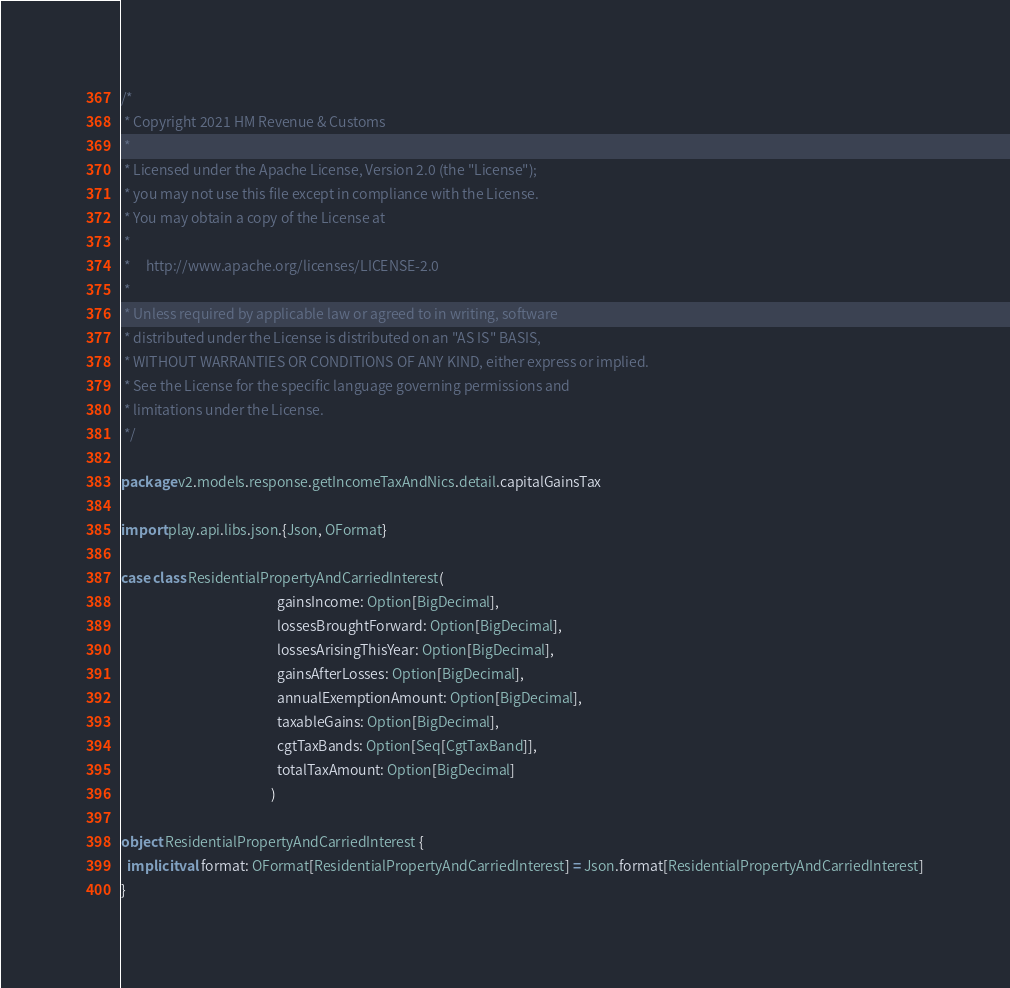Convert code to text. <code><loc_0><loc_0><loc_500><loc_500><_Scala_>/*
 * Copyright 2021 HM Revenue & Customs
 *
 * Licensed under the Apache License, Version 2.0 (the "License");
 * you may not use this file except in compliance with the License.
 * You may obtain a copy of the License at
 *
 *     http://www.apache.org/licenses/LICENSE-2.0
 *
 * Unless required by applicable law or agreed to in writing, software
 * distributed under the License is distributed on an "AS IS" BASIS,
 * WITHOUT WARRANTIES OR CONDITIONS OF ANY KIND, either express or implied.
 * See the License for the specific language governing permissions and
 * limitations under the License.
 */

package v2.models.response.getIncomeTaxAndNics.detail.capitalGainsTax

import play.api.libs.json.{Json, OFormat}

case class ResidentialPropertyAndCarriedInterest(
                                                  gainsIncome: Option[BigDecimal],
                                                  lossesBroughtForward: Option[BigDecimal],
                                                  lossesArisingThisYear: Option[BigDecimal],
                                                  gainsAfterLosses: Option[BigDecimal],
                                                  annualExemptionAmount: Option[BigDecimal],
                                                  taxableGains: Option[BigDecimal],
                                                  cgtTaxBands: Option[Seq[CgtTaxBand]],
                                                  totalTaxAmount: Option[BigDecimal]
                                                )

object ResidentialPropertyAndCarriedInterest {
  implicit val format: OFormat[ResidentialPropertyAndCarriedInterest] = Json.format[ResidentialPropertyAndCarriedInterest]
}
</code> 